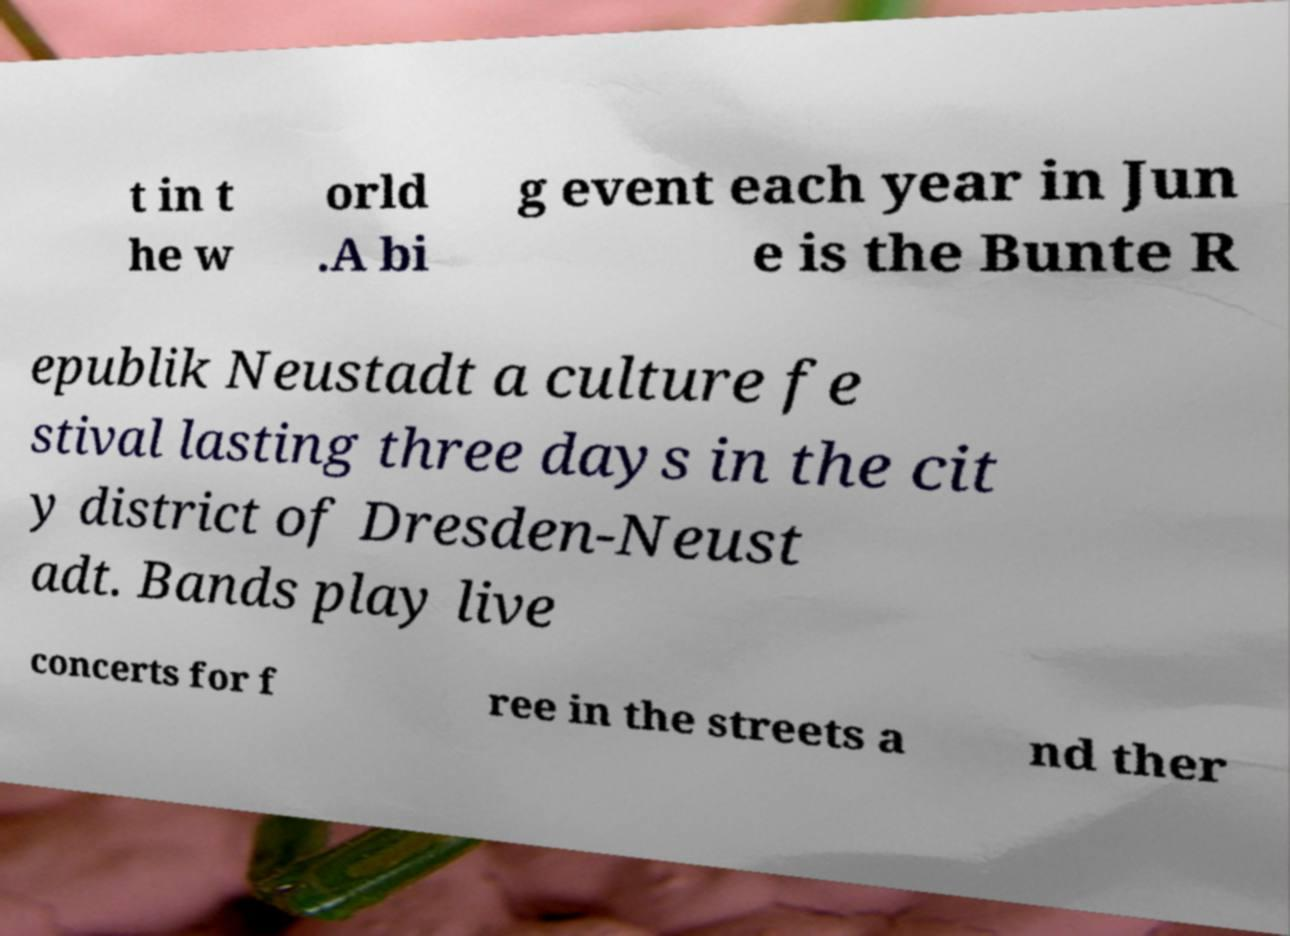There's text embedded in this image that I need extracted. Can you transcribe it verbatim? t in t he w orld .A bi g event each year in Jun e is the Bunte R epublik Neustadt a culture fe stival lasting three days in the cit y district of Dresden-Neust adt. Bands play live concerts for f ree in the streets a nd ther 